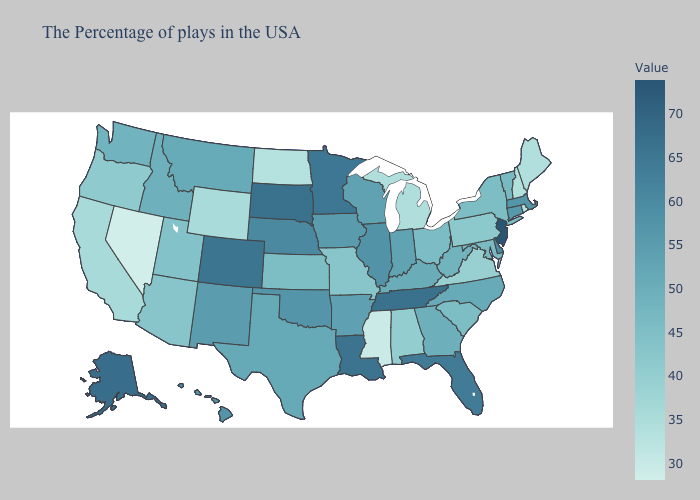Does the map have missing data?
Quick response, please. No. Which states have the highest value in the USA?
Short answer required. New Jersey. Does Tennessee have the highest value in the South?
Concise answer only. Yes. Does Nevada have the lowest value in the USA?
Answer briefly. Yes. Is the legend a continuous bar?
Concise answer only. Yes. Does Nevada have the lowest value in the USA?
Give a very brief answer. Yes. Which states have the lowest value in the USA?
Give a very brief answer. Nevada. Does Delaware have the highest value in the South?
Answer briefly. No. 